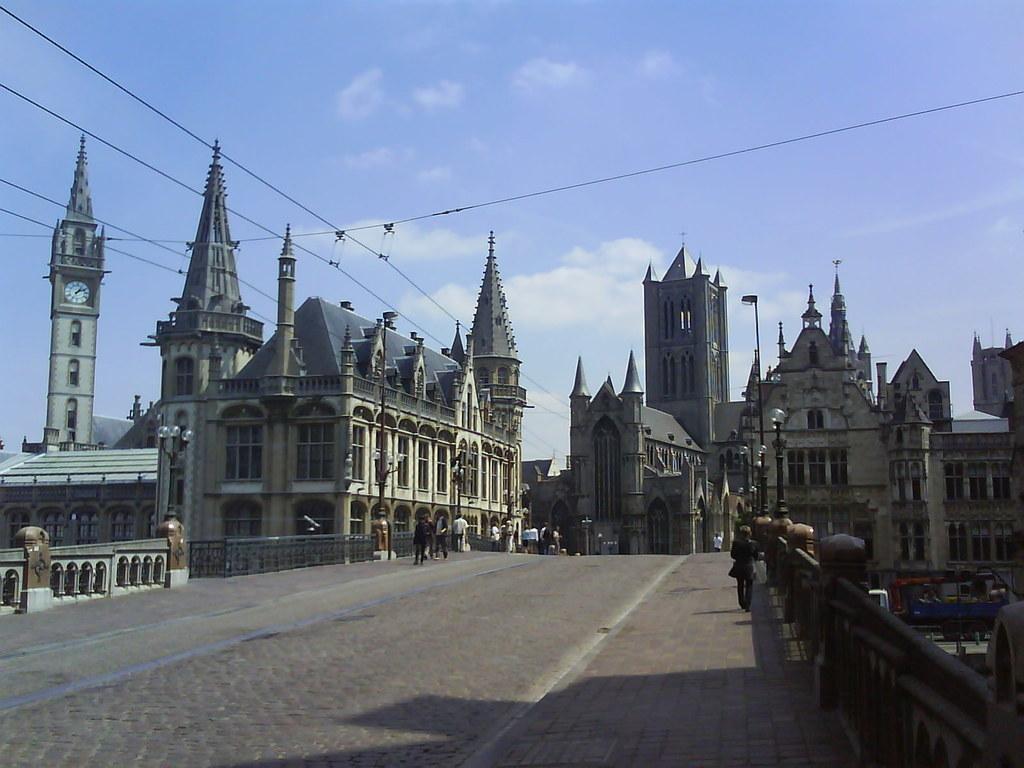Describe this image in one or two sentences. In this picture we can see some buildings and a clock tower in the middle of the image. In the front bottom side we can see some people walking on the bridge. On the top we can see the sky and clouds. 